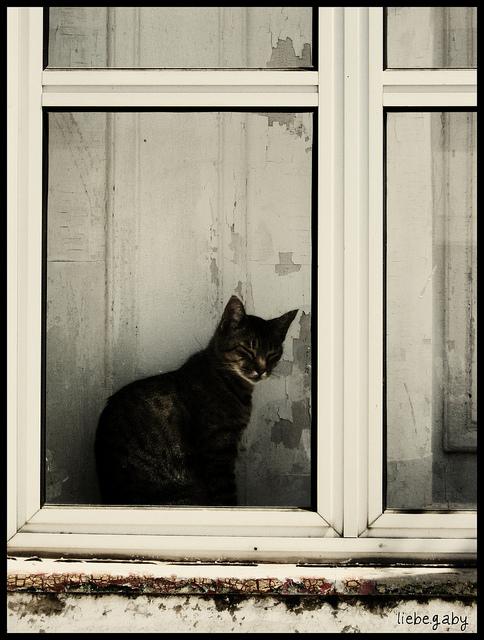Does the window need some paint?
Quick response, please. Yes. What is the wall made of?
Be succinct. Wood. Does the cat want to go outside?
Answer briefly. Yes. What color is the window?
Concise answer only. White. 